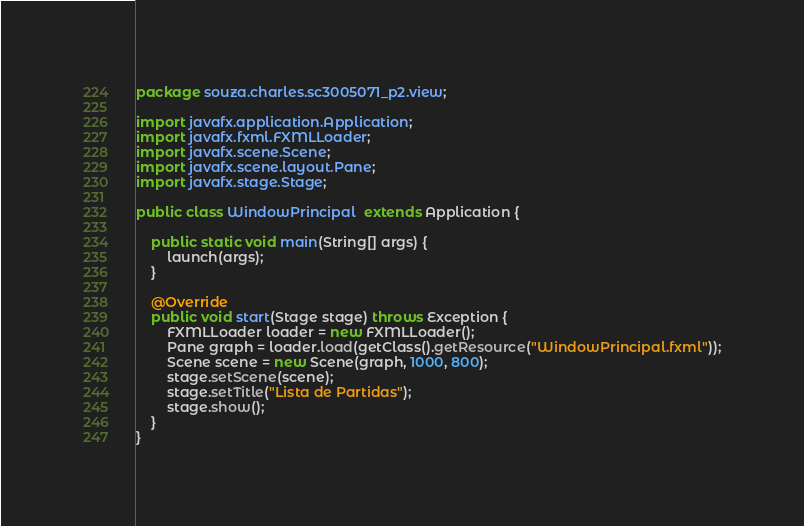<code> <loc_0><loc_0><loc_500><loc_500><_Java_>package souza.charles.sc3005071_p2.view;

import javafx.application.Application;
import javafx.fxml.FXMLLoader;
import javafx.scene.Scene;
import javafx.scene.layout.Pane;
import javafx.stage.Stage;

public class WindowPrincipal  extends Application {

    public static void main(String[] args) {
        launch(args);
    }

    @Override
    public void start(Stage stage) throws Exception {
        FXMLLoader loader = new FXMLLoader();
        Pane graph = loader.load(getClass().getResource("WindowPrincipal.fxml"));
        Scene scene = new Scene(graph, 1000, 800);
        stage.setScene(scene);
        stage.setTitle("Lista de Partidas");
        stage.show();
    }
}</code> 